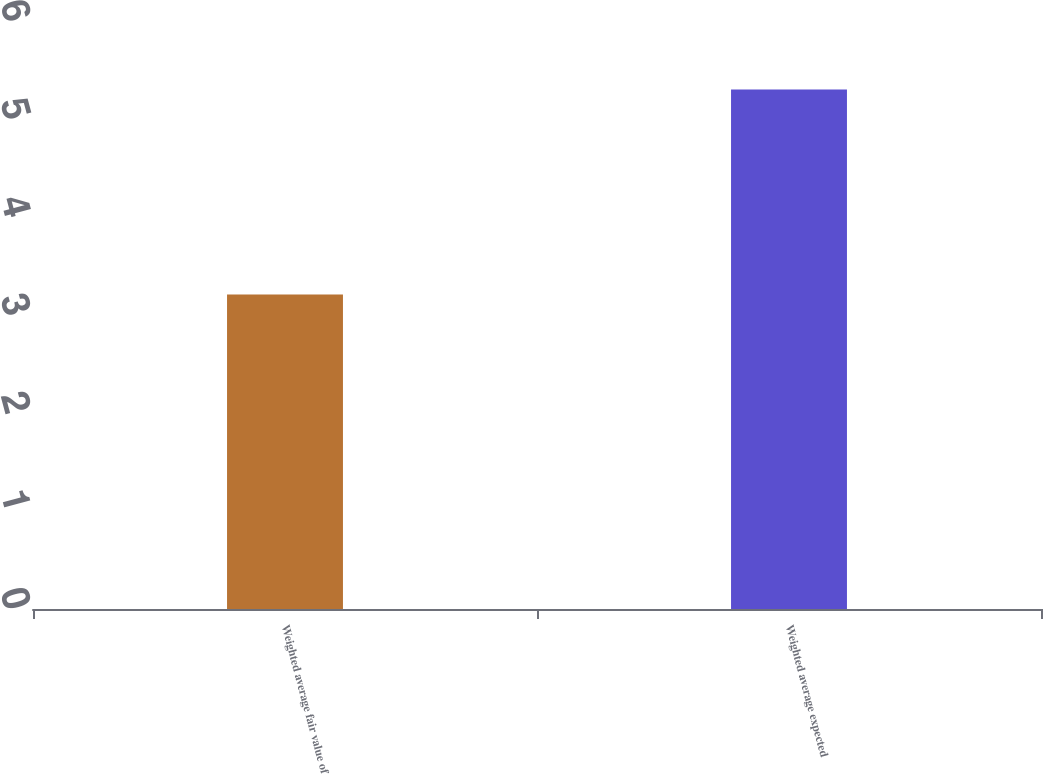Convert chart. <chart><loc_0><loc_0><loc_500><loc_500><bar_chart><fcel>Weighted average fair value of<fcel>Weighted average expected<nl><fcel>3.21<fcel>5.3<nl></chart> 